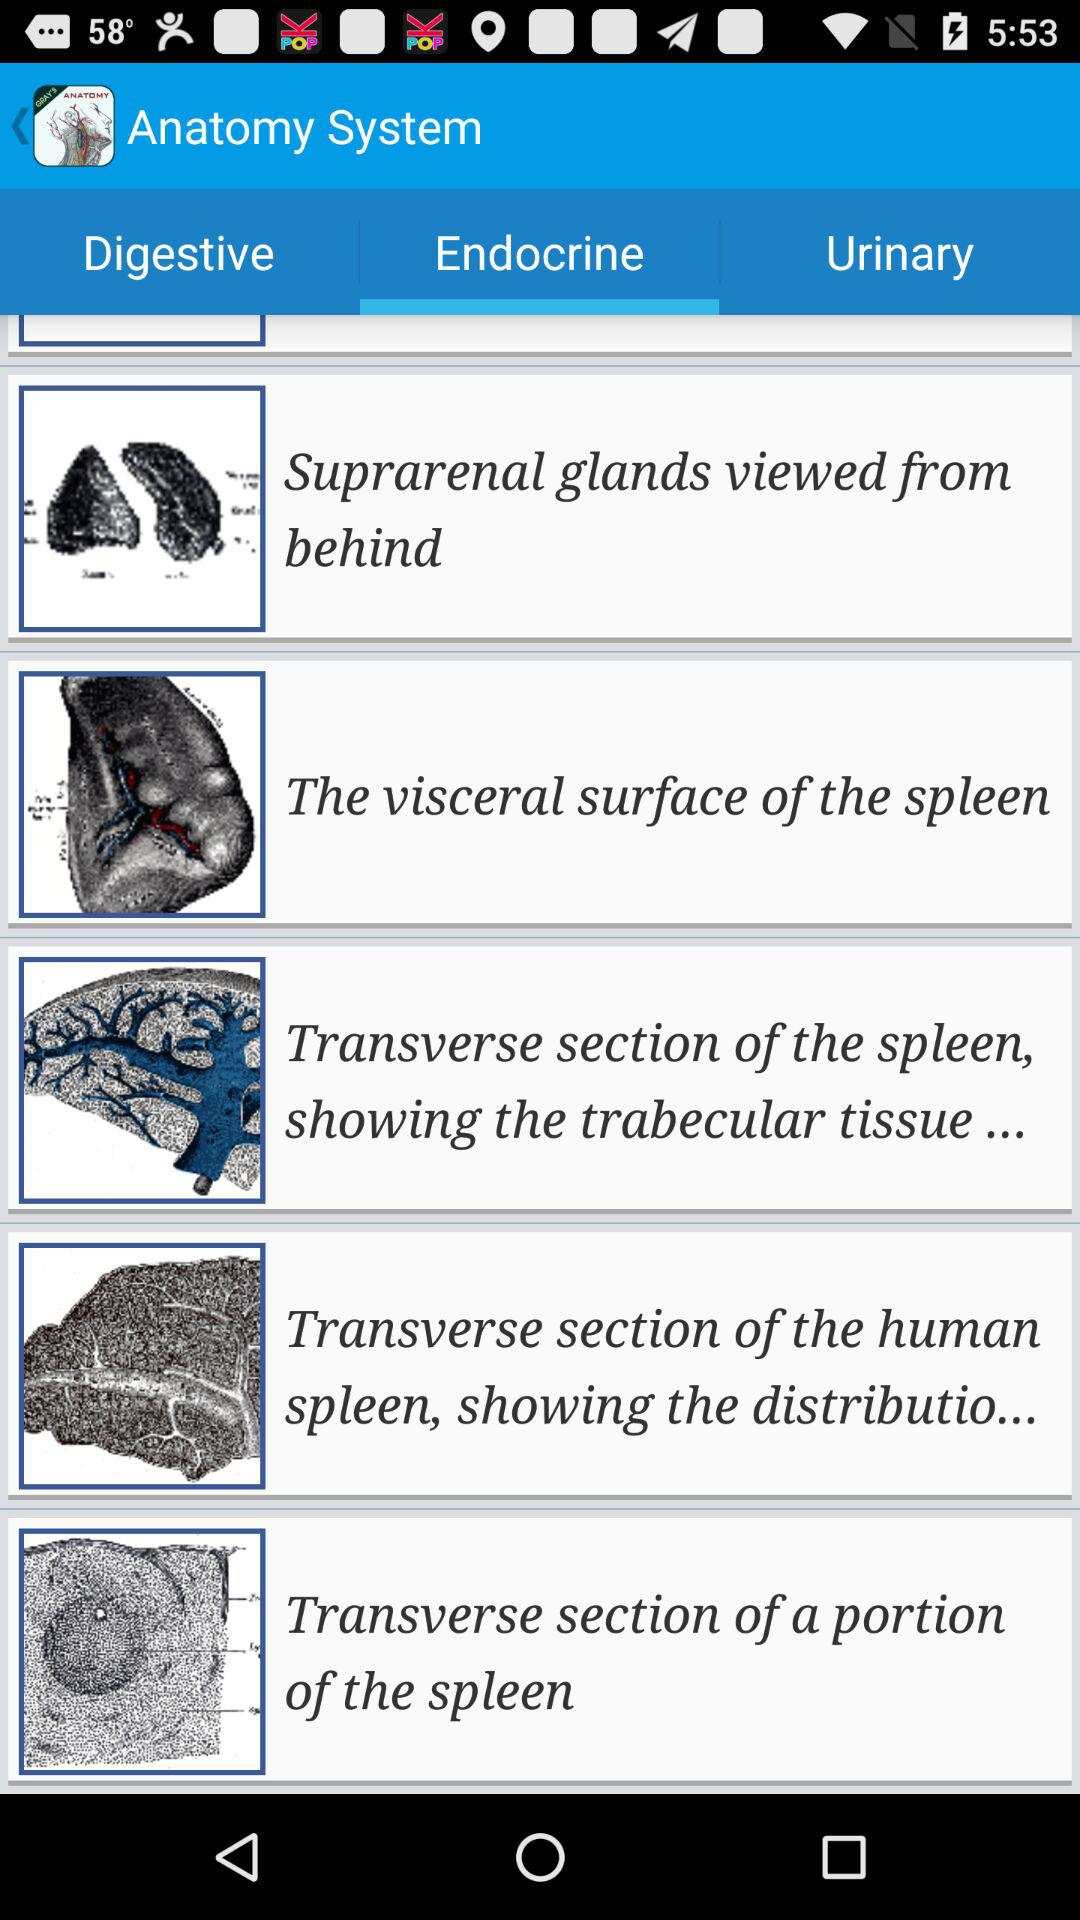Which organs belong to the digestive system?
When the provided information is insufficient, respond with <no answer>. <no answer> 